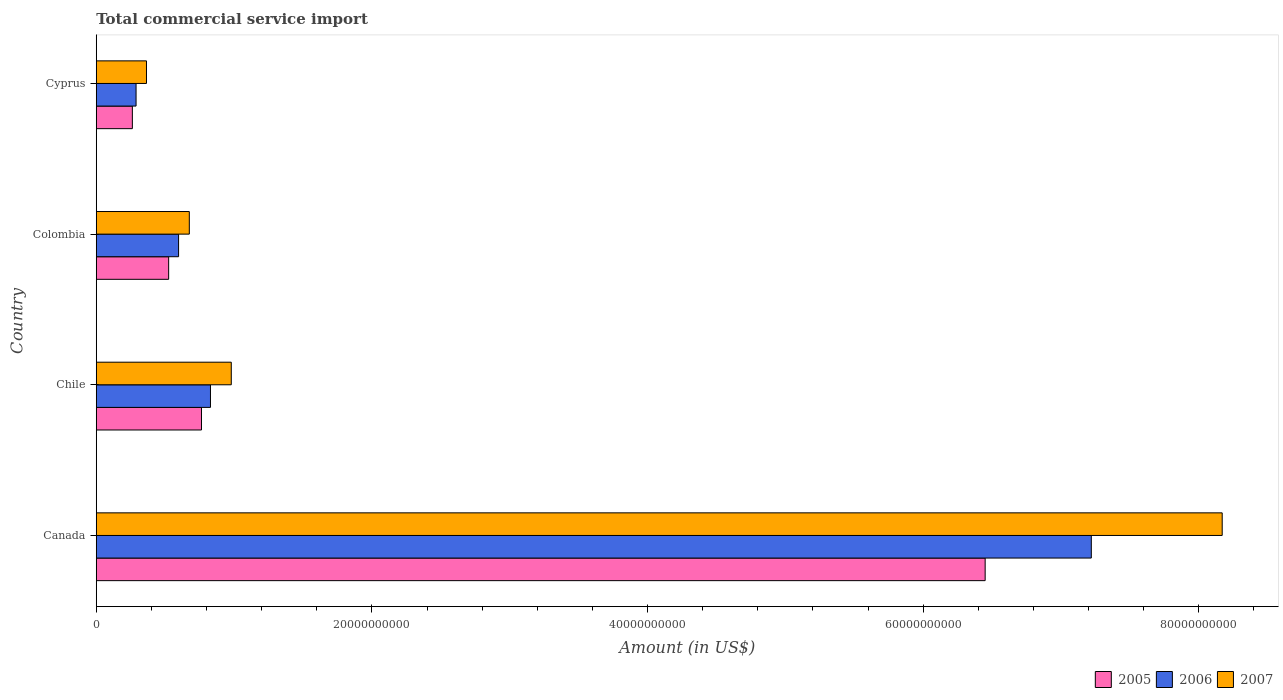Are the number of bars per tick equal to the number of legend labels?
Your response must be concise. Yes. How many bars are there on the 4th tick from the top?
Give a very brief answer. 3. How many bars are there on the 3rd tick from the bottom?
Your answer should be compact. 3. What is the total commercial service import in 2005 in Cyprus?
Keep it short and to the point. 2.62e+09. Across all countries, what is the maximum total commercial service import in 2005?
Keep it short and to the point. 6.45e+1. Across all countries, what is the minimum total commercial service import in 2007?
Give a very brief answer. 3.64e+09. In which country was the total commercial service import in 2007 maximum?
Make the answer very short. Canada. In which country was the total commercial service import in 2006 minimum?
Your answer should be compact. Cyprus. What is the total total commercial service import in 2005 in the graph?
Your answer should be compact. 8.00e+1. What is the difference between the total commercial service import in 2005 in Canada and that in Colombia?
Provide a short and direct response. 5.92e+1. What is the difference between the total commercial service import in 2005 in Canada and the total commercial service import in 2007 in Cyprus?
Ensure brevity in your answer.  6.09e+1. What is the average total commercial service import in 2005 per country?
Your response must be concise. 2.00e+1. What is the difference between the total commercial service import in 2005 and total commercial service import in 2007 in Cyprus?
Offer a very short reply. -1.02e+09. In how many countries, is the total commercial service import in 2006 greater than 68000000000 US$?
Keep it short and to the point. 1. What is the ratio of the total commercial service import in 2007 in Colombia to that in Cyprus?
Provide a succinct answer. 1.85. Is the difference between the total commercial service import in 2005 in Canada and Colombia greater than the difference between the total commercial service import in 2007 in Canada and Colombia?
Provide a short and direct response. No. What is the difference between the highest and the second highest total commercial service import in 2005?
Ensure brevity in your answer.  5.69e+1. What is the difference between the highest and the lowest total commercial service import in 2006?
Your answer should be compact. 6.93e+1. Is the sum of the total commercial service import in 2007 in Chile and Cyprus greater than the maximum total commercial service import in 2006 across all countries?
Give a very brief answer. No. What does the 3rd bar from the top in Chile represents?
Offer a terse response. 2005. Is it the case that in every country, the sum of the total commercial service import in 2005 and total commercial service import in 2007 is greater than the total commercial service import in 2006?
Provide a succinct answer. Yes. What is the difference between two consecutive major ticks on the X-axis?
Make the answer very short. 2.00e+1. Where does the legend appear in the graph?
Ensure brevity in your answer.  Bottom right. How many legend labels are there?
Your answer should be compact. 3. How are the legend labels stacked?
Provide a short and direct response. Horizontal. What is the title of the graph?
Your answer should be very brief. Total commercial service import. Does "2006" appear as one of the legend labels in the graph?
Give a very brief answer. Yes. What is the label or title of the X-axis?
Make the answer very short. Amount (in US$). What is the Amount (in US$) in 2005 in Canada?
Give a very brief answer. 6.45e+1. What is the Amount (in US$) in 2006 in Canada?
Keep it short and to the point. 7.22e+1. What is the Amount (in US$) of 2007 in Canada?
Offer a terse response. 8.17e+1. What is the Amount (in US$) in 2005 in Chile?
Provide a succinct answer. 7.63e+09. What is the Amount (in US$) in 2006 in Chile?
Make the answer very short. 8.29e+09. What is the Amount (in US$) of 2007 in Chile?
Your answer should be very brief. 9.80e+09. What is the Amount (in US$) of 2005 in Colombia?
Keep it short and to the point. 5.25e+09. What is the Amount (in US$) in 2006 in Colombia?
Your response must be concise. 5.97e+09. What is the Amount (in US$) of 2007 in Colombia?
Provide a succinct answer. 6.75e+09. What is the Amount (in US$) of 2005 in Cyprus?
Your response must be concise. 2.62e+09. What is the Amount (in US$) of 2006 in Cyprus?
Your response must be concise. 2.89e+09. What is the Amount (in US$) in 2007 in Cyprus?
Your answer should be very brief. 3.64e+09. Across all countries, what is the maximum Amount (in US$) of 2005?
Make the answer very short. 6.45e+1. Across all countries, what is the maximum Amount (in US$) in 2006?
Your response must be concise. 7.22e+1. Across all countries, what is the maximum Amount (in US$) of 2007?
Keep it short and to the point. 8.17e+1. Across all countries, what is the minimum Amount (in US$) of 2005?
Give a very brief answer. 2.62e+09. Across all countries, what is the minimum Amount (in US$) of 2006?
Offer a terse response. 2.89e+09. Across all countries, what is the minimum Amount (in US$) of 2007?
Provide a succinct answer. 3.64e+09. What is the total Amount (in US$) of 2005 in the graph?
Give a very brief answer. 8.00e+1. What is the total Amount (in US$) in 2006 in the graph?
Keep it short and to the point. 8.93e+1. What is the total Amount (in US$) of 2007 in the graph?
Make the answer very short. 1.02e+11. What is the difference between the Amount (in US$) of 2005 in Canada and that in Chile?
Give a very brief answer. 5.69e+1. What is the difference between the Amount (in US$) of 2006 in Canada and that in Chile?
Your answer should be compact. 6.39e+1. What is the difference between the Amount (in US$) of 2007 in Canada and that in Chile?
Give a very brief answer. 7.19e+1. What is the difference between the Amount (in US$) in 2005 in Canada and that in Colombia?
Ensure brevity in your answer.  5.92e+1. What is the difference between the Amount (in US$) of 2006 in Canada and that in Colombia?
Your answer should be very brief. 6.62e+1. What is the difference between the Amount (in US$) in 2007 in Canada and that in Colombia?
Your answer should be very brief. 7.49e+1. What is the difference between the Amount (in US$) in 2005 in Canada and that in Cyprus?
Offer a very short reply. 6.19e+1. What is the difference between the Amount (in US$) in 2006 in Canada and that in Cyprus?
Make the answer very short. 6.93e+1. What is the difference between the Amount (in US$) of 2007 in Canada and that in Cyprus?
Give a very brief answer. 7.81e+1. What is the difference between the Amount (in US$) in 2005 in Chile and that in Colombia?
Give a very brief answer. 2.38e+09. What is the difference between the Amount (in US$) of 2006 in Chile and that in Colombia?
Your response must be concise. 2.31e+09. What is the difference between the Amount (in US$) in 2007 in Chile and that in Colombia?
Give a very brief answer. 3.04e+09. What is the difference between the Amount (in US$) of 2005 in Chile and that in Cyprus?
Offer a terse response. 5.02e+09. What is the difference between the Amount (in US$) of 2006 in Chile and that in Cyprus?
Make the answer very short. 5.40e+09. What is the difference between the Amount (in US$) in 2007 in Chile and that in Cyprus?
Your response must be concise. 6.15e+09. What is the difference between the Amount (in US$) in 2005 in Colombia and that in Cyprus?
Your answer should be very brief. 2.63e+09. What is the difference between the Amount (in US$) of 2006 in Colombia and that in Cyprus?
Keep it short and to the point. 3.09e+09. What is the difference between the Amount (in US$) in 2007 in Colombia and that in Cyprus?
Your answer should be very brief. 3.11e+09. What is the difference between the Amount (in US$) in 2005 in Canada and the Amount (in US$) in 2006 in Chile?
Ensure brevity in your answer.  5.62e+1. What is the difference between the Amount (in US$) in 2005 in Canada and the Amount (in US$) in 2007 in Chile?
Give a very brief answer. 5.47e+1. What is the difference between the Amount (in US$) of 2006 in Canada and the Amount (in US$) of 2007 in Chile?
Your answer should be very brief. 6.24e+1. What is the difference between the Amount (in US$) of 2005 in Canada and the Amount (in US$) of 2006 in Colombia?
Your answer should be very brief. 5.85e+1. What is the difference between the Amount (in US$) of 2005 in Canada and the Amount (in US$) of 2007 in Colombia?
Offer a very short reply. 5.77e+1. What is the difference between the Amount (in US$) of 2006 in Canada and the Amount (in US$) of 2007 in Colombia?
Keep it short and to the point. 6.54e+1. What is the difference between the Amount (in US$) in 2005 in Canada and the Amount (in US$) in 2006 in Cyprus?
Provide a short and direct response. 6.16e+1. What is the difference between the Amount (in US$) of 2005 in Canada and the Amount (in US$) of 2007 in Cyprus?
Keep it short and to the point. 6.09e+1. What is the difference between the Amount (in US$) of 2006 in Canada and the Amount (in US$) of 2007 in Cyprus?
Keep it short and to the point. 6.86e+1. What is the difference between the Amount (in US$) of 2005 in Chile and the Amount (in US$) of 2006 in Colombia?
Make the answer very short. 1.66e+09. What is the difference between the Amount (in US$) of 2005 in Chile and the Amount (in US$) of 2007 in Colombia?
Give a very brief answer. 8.83e+08. What is the difference between the Amount (in US$) in 2006 in Chile and the Amount (in US$) in 2007 in Colombia?
Ensure brevity in your answer.  1.54e+09. What is the difference between the Amount (in US$) in 2005 in Chile and the Amount (in US$) in 2006 in Cyprus?
Give a very brief answer. 4.75e+09. What is the difference between the Amount (in US$) in 2005 in Chile and the Amount (in US$) in 2007 in Cyprus?
Your answer should be compact. 3.99e+09. What is the difference between the Amount (in US$) in 2006 in Chile and the Amount (in US$) in 2007 in Cyprus?
Offer a terse response. 4.64e+09. What is the difference between the Amount (in US$) in 2005 in Colombia and the Amount (in US$) in 2006 in Cyprus?
Your answer should be very brief. 2.36e+09. What is the difference between the Amount (in US$) of 2005 in Colombia and the Amount (in US$) of 2007 in Cyprus?
Provide a short and direct response. 1.61e+09. What is the difference between the Amount (in US$) in 2006 in Colombia and the Amount (in US$) in 2007 in Cyprus?
Your response must be concise. 2.33e+09. What is the average Amount (in US$) in 2005 per country?
Offer a terse response. 2.00e+1. What is the average Amount (in US$) of 2006 per country?
Your response must be concise. 2.23e+1. What is the average Amount (in US$) in 2007 per country?
Give a very brief answer. 2.55e+1. What is the difference between the Amount (in US$) of 2005 and Amount (in US$) of 2006 in Canada?
Give a very brief answer. -7.70e+09. What is the difference between the Amount (in US$) in 2005 and Amount (in US$) in 2007 in Canada?
Provide a short and direct response. -1.72e+1. What is the difference between the Amount (in US$) in 2006 and Amount (in US$) in 2007 in Canada?
Keep it short and to the point. -9.50e+09. What is the difference between the Amount (in US$) of 2005 and Amount (in US$) of 2006 in Chile?
Keep it short and to the point. -6.52e+08. What is the difference between the Amount (in US$) in 2005 and Amount (in US$) in 2007 in Chile?
Your answer should be compact. -2.16e+09. What is the difference between the Amount (in US$) in 2006 and Amount (in US$) in 2007 in Chile?
Offer a very short reply. -1.51e+09. What is the difference between the Amount (in US$) in 2005 and Amount (in US$) in 2006 in Colombia?
Your response must be concise. -7.20e+08. What is the difference between the Amount (in US$) of 2005 and Amount (in US$) of 2007 in Colombia?
Offer a terse response. -1.50e+09. What is the difference between the Amount (in US$) of 2006 and Amount (in US$) of 2007 in Colombia?
Make the answer very short. -7.78e+08. What is the difference between the Amount (in US$) in 2005 and Amount (in US$) in 2006 in Cyprus?
Your answer should be compact. -2.68e+08. What is the difference between the Amount (in US$) of 2005 and Amount (in US$) of 2007 in Cyprus?
Offer a terse response. -1.02e+09. What is the difference between the Amount (in US$) of 2006 and Amount (in US$) of 2007 in Cyprus?
Offer a terse response. -7.56e+08. What is the ratio of the Amount (in US$) in 2005 in Canada to that in Chile?
Your answer should be very brief. 8.45. What is the ratio of the Amount (in US$) of 2006 in Canada to that in Chile?
Make the answer very short. 8.71. What is the ratio of the Amount (in US$) in 2007 in Canada to that in Chile?
Give a very brief answer. 8.34. What is the ratio of the Amount (in US$) in 2005 in Canada to that in Colombia?
Your answer should be very brief. 12.28. What is the ratio of the Amount (in US$) in 2006 in Canada to that in Colombia?
Provide a short and direct response. 12.09. What is the ratio of the Amount (in US$) in 2007 in Canada to that in Colombia?
Your answer should be very brief. 12.1. What is the ratio of the Amount (in US$) of 2005 in Canada to that in Cyprus?
Provide a short and direct response. 24.62. What is the ratio of the Amount (in US$) of 2006 in Canada to that in Cyprus?
Offer a terse response. 25. What is the ratio of the Amount (in US$) of 2007 in Canada to that in Cyprus?
Ensure brevity in your answer.  22.42. What is the ratio of the Amount (in US$) of 2005 in Chile to that in Colombia?
Your answer should be very brief. 1.45. What is the ratio of the Amount (in US$) in 2006 in Chile to that in Colombia?
Provide a succinct answer. 1.39. What is the ratio of the Amount (in US$) of 2007 in Chile to that in Colombia?
Offer a very short reply. 1.45. What is the ratio of the Amount (in US$) of 2005 in Chile to that in Cyprus?
Your answer should be very brief. 2.91. What is the ratio of the Amount (in US$) of 2006 in Chile to that in Cyprus?
Provide a short and direct response. 2.87. What is the ratio of the Amount (in US$) in 2007 in Chile to that in Cyprus?
Your answer should be very brief. 2.69. What is the ratio of the Amount (in US$) of 2005 in Colombia to that in Cyprus?
Give a very brief answer. 2.01. What is the ratio of the Amount (in US$) in 2006 in Colombia to that in Cyprus?
Your answer should be compact. 2.07. What is the ratio of the Amount (in US$) of 2007 in Colombia to that in Cyprus?
Offer a very short reply. 1.85. What is the difference between the highest and the second highest Amount (in US$) in 2005?
Offer a very short reply. 5.69e+1. What is the difference between the highest and the second highest Amount (in US$) in 2006?
Give a very brief answer. 6.39e+1. What is the difference between the highest and the second highest Amount (in US$) in 2007?
Give a very brief answer. 7.19e+1. What is the difference between the highest and the lowest Amount (in US$) in 2005?
Your answer should be very brief. 6.19e+1. What is the difference between the highest and the lowest Amount (in US$) of 2006?
Give a very brief answer. 6.93e+1. What is the difference between the highest and the lowest Amount (in US$) in 2007?
Provide a short and direct response. 7.81e+1. 